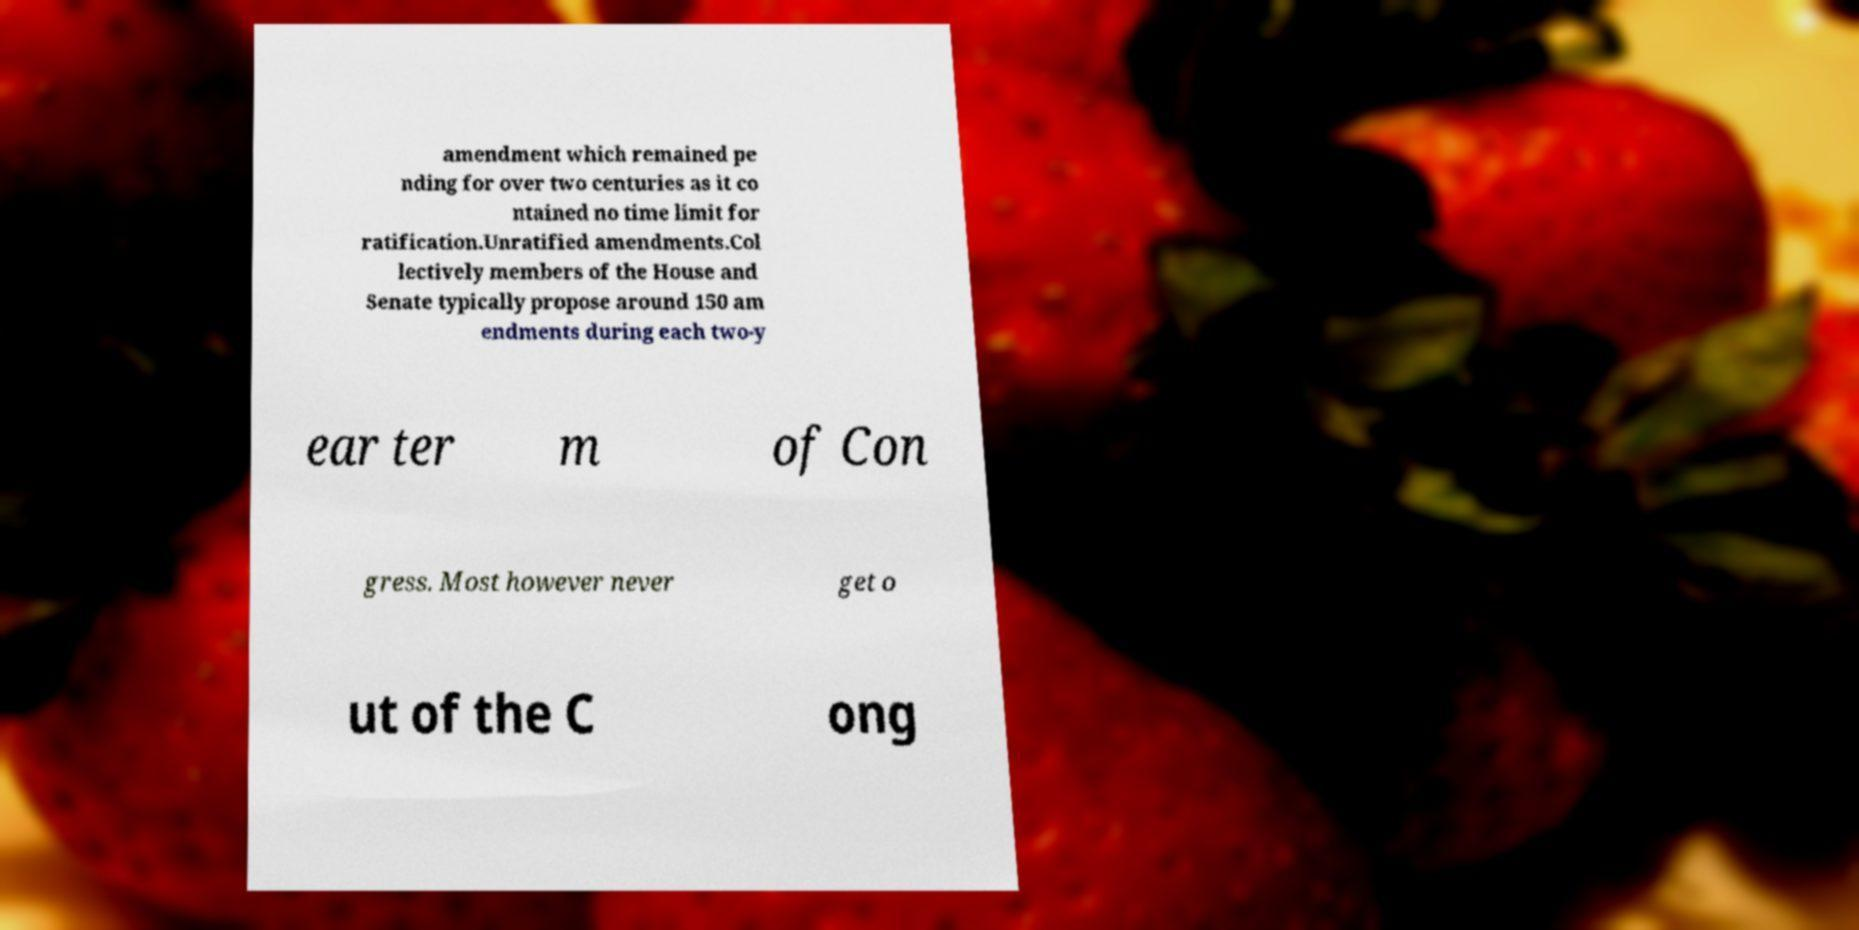Could you extract and type out the text from this image? amendment which remained pe nding for over two centuries as it co ntained no time limit for ratification.Unratified amendments.Col lectively members of the House and Senate typically propose around 150 am endments during each two-y ear ter m of Con gress. Most however never get o ut of the C ong 